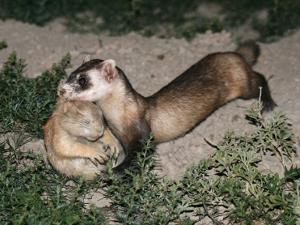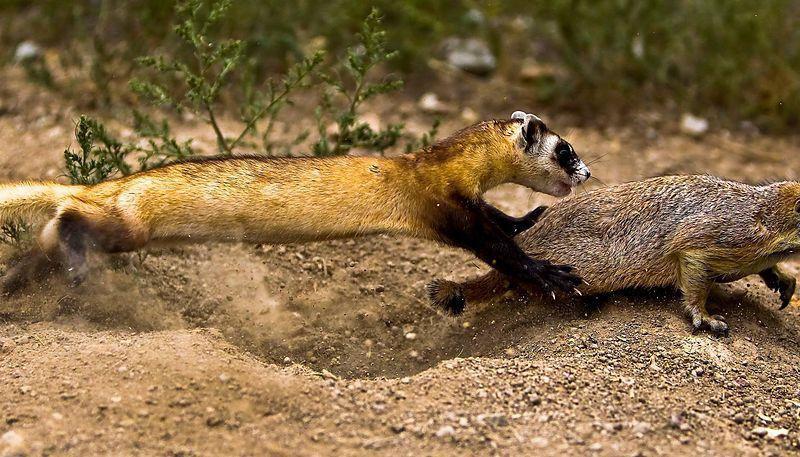The first image is the image on the left, the second image is the image on the right. Given the left and right images, does the statement "There are exactly two animals in the image on the left." hold true? Answer yes or no. Yes. The first image is the image on the left, the second image is the image on the right. Given the left and right images, does the statement "Right image shows a ferret pursuing a different breed of animal outdoors." hold true? Answer yes or no. Yes. 